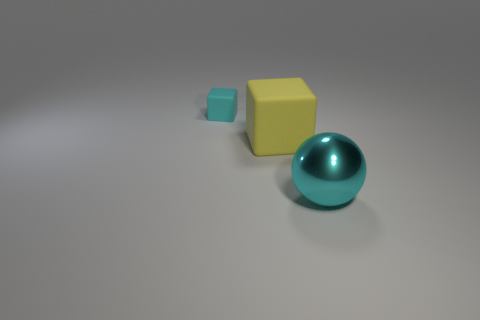Is there any other thing that has the same size as the cyan rubber thing?
Your answer should be compact. No. Are there any other things that are made of the same material as the ball?
Keep it short and to the point. No. There is a thing in front of the block that is right of the small rubber object; is there a cyan object to the left of it?
Your answer should be very brief. Yes. What is the material of the tiny cyan cube?
Provide a short and direct response. Rubber. What number of other things are there of the same shape as the big yellow object?
Offer a terse response. 1. Do the yellow rubber thing and the metallic thing have the same shape?
Provide a succinct answer. No. How many things are things behind the cyan shiny object or cyan cubes that are behind the big shiny thing?
Keep it short and to the point. 2. What number of things are either big cyan shiny things or cubes?
Offer a terse response. 3. There is a cyan thing on the right side of the tiny thing; how many big cubes are in front of it?
Keep it short and to the point. 0. How many other objects are the same size as the cyan matte block?
Your answer should be very brief. 0. 